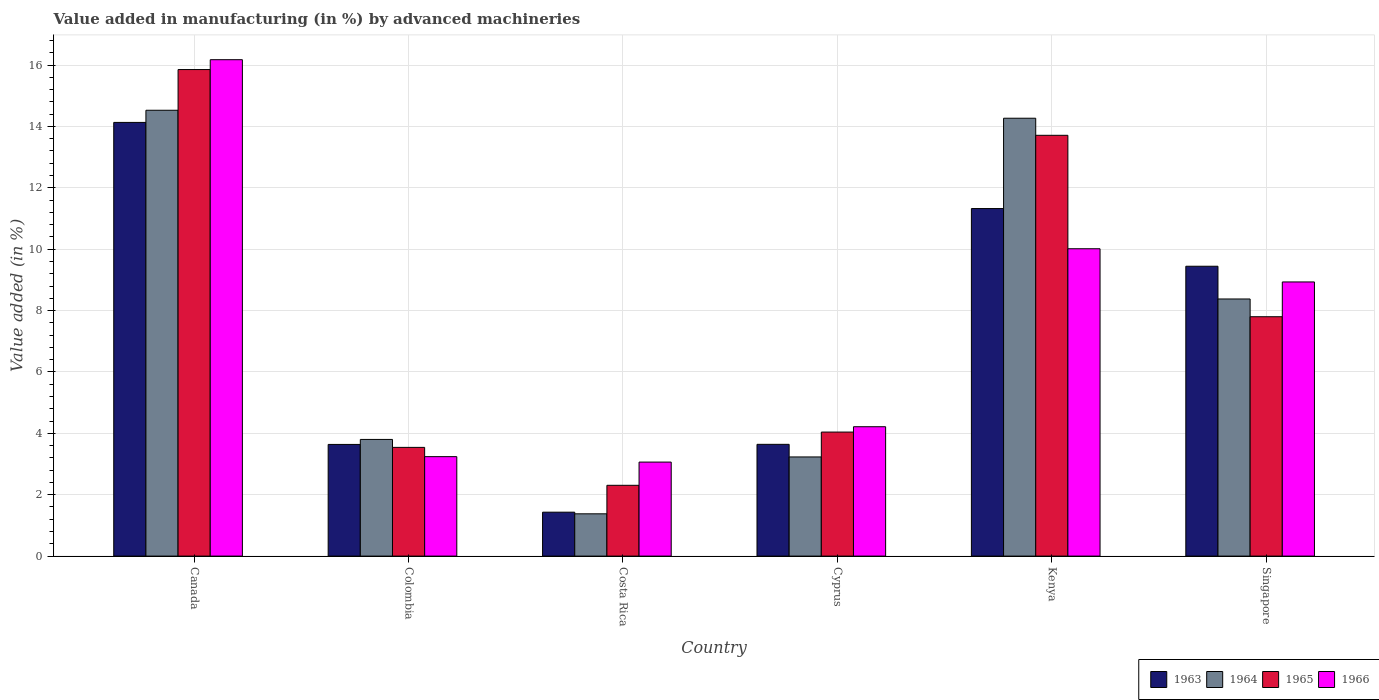What is the label of the 1st group of bars from the left?
Ensure brevity in your answer.  Canada. In how many cases, is the number of bars for a given country not equal to the number of legend labels?
Keep it short and to the point. 0. What is the percentage of value added in manufacturing by advanced machineries in 1966 in Kenya?
Offer a very short reply. 10.01. Across all countries, what is the maximum percentage of value added in manufacturing by advanced machineries in 1966?
Give a very brief answer. 16.17. Across all countries, what is the minimum percentage of value added in manufacturing by advanced machineries in 1964?
Offer a very short reply. 1.38. In which country was the percentage of value added in manufacturing by advanced machineries in 1964 minimum?
Your response must be concise. Costa Rica. What is the total percentage of value added in manufacturing by advanced machineries in 1964 in the graph?
Offer a terse response. 45.58. What is the difference between the percentage of value added in manufacturing by advanced machineries in 1964 in Canada and that in Cyprus?
Make the answer very short. 11.3. What is the difference between the percentage of value added in manufacturing by advanced machineries in 1966 in Singapore and the percentage of value added in manufacturing by advanced machineries in 1963 in Kenya?
Offer a very short reply. -2.39. What is the average percentage of value added in manufacturing by advanced machineries in 1963 per country?
Keep it short and to the point. 7.27. What is the difference between the percentage of value added in manufacturing by advanced machineries of/in 1964 and percentage of value added in manufacturing by advanced machineries of/in 1965 in Canada?
Give a very brief answer. -1.33. In how many countries, is the percentage of value added in manufacturing by advanced machineries in 1966 greater than 0.8 %?
Make the answer very short. 6. What is the ratio of the percentage of value added in manufacturing by advanced machineries in 1964 in Costa Rica to that in Kenya?
Your response must be concise. 0.1. What is the difference between the highest and the second highest percentage of value added in manufacturing by advanced machineries in 1966?
Make the answer very short. 7.24. What is the difference between the highest and the lowest percentage of value added in manufacturing by advanced machineries in 1965?
Your answer should be compact. 13.55. In how many countries, is the percentage of value added in manufacturing by advanced machineries in 1963 greater than the average percentage of value added in manufacturing by advanced machineries in 1963 taken over all countries?
Your answer should be compact. 3. What does the 1st bar from the left in Kenya represents?
Give a very brief answer. 1963. What does the 4th bar from the right in Costa Rica represents?
Offer a terse response. 1963. Is it the case that in every country, the sum of the percentage of value added in manufacturing by advanced machineries in 1965 and percentage of value added in manufacturing by advanced machineries in 1964 is greater than the percentage of value added in manufacturing by advanced machineries in 1966?
Give a very brief answer. Yes. How many countries are there in the graph?
Ensure brevity in your answer.  6. What is the difference between two consecutive major ticks on the Y-axis?
Your response must be concise. 2. Are the values on the major ticks of Y-axis written in scientific E-notation?
Your answer should be very brief. No. Does the graph contain any zero values?
Make the answer very short. No. How many legend labels are there?
Provide a short and direct response. 4. What is the title of the graph?
Ensure brevity in your answer.  Value added in manufacturing (in %) by advanced machineries. Does "1996" appear as one of the legend labels in the graph?
Ensure brevity in your answer.  No. What is the label or title of the Y-axis?
Offer a very short reply. Value added (in %). What is the Value added (in %) of 1963 in Canada?
Keep it short and to the point. 14.13. What is the Value added (in %) of 1964 in Canada?
Keep it short and to the point. 14.53. What is the Value added (in %) of 1965 in Canada?
Your response must be concise. 15.85. What is the Value added (in %) of 1966 in Canada?
Offer a terse response. 16.17. What is the Value added (in %) in 1963 in Colombia?
Ensure brevity in your answer.  3.64. What is the Value added (in %) of 1964 in Colombia?
Keep it short and to the point. 3.8. What is the Value added (in %) of 1965 in Colombia?
Your response must be concise. 3.54. What is the Value added (in %) of 1966 in Colombia?
Offer a terse response. 3.24. What is the Value added (in %) in 1963 in Costa Rica?
Give a very brief answer. 1.43. What is the Value added (in %) of 1964 in Costa Rica?
Offer a terse response. 1.38. What is the Value added (in %) of 1965 in Costa Rica?
Provide a short and direct response. 2.31. What is the Value added (in %) in 1966 in Costa Rica?
Provide a short and direct response. 3.06. What is the Value added (in %) in 1963 in Cyprus?
Make the answer very short. 3.64. What is the Value added (in %) of 1964 in Cyprus?
Provide a short and direct response. 3.23. What is the Value added (in %) in 1965 in Cyprus?
Provide a succinct answer. 4.04. What is the Value added (in %) of 1966 in Cyprus?
Keep it short and to the point. 4.22. What is the Value added (in %) of 1963 in Kenya?
Make the answer very short. 11.32. What is the Value added (in %) in 1964 in Kenya?
Your response must be concise. 14.27. What is the Value added (in %) of 1965 in Kenya?
Offer a terse response. 13.71. What is the Value added (in %) in 1966 in Kenya?
Your response must be concise. 10.01. What is the Value added (in %) of 1963 in Singapore?
Provide a succinct answer. 9.44. What is the Value added (in %) in 1964 in Singapore?
Your answer should be very brief. 8.38. What is the Value added (in %) in 1965 in Singapore?
Make the answer very short. 7.8. What is the Value added (in %) of 1966 in Singapore?
Provide a succinct answer. 8.93. Across all countries, what is the maximum Value added (in %) in 1963?
Give a very brief answer. 14.13. Across all countries, what is the maximum Value added (in %) in 1964?
Keep it short and to the point. 14.53. Across all countries, what is the maximum Value added (in %) in 1965?
Make the answer very short. 15.85. Across all countries, what is the maximum Value added (in %) of 1966?
Offer a terse response. 16.17. Across all countries, what is the minimum Value added (in %) in 1963?
Make the answer very short. 1.43. Across all countries, what is the minimum Value added (in %) in 1964?
Your answer should be compact. 1.38. Across all countries, what is the minimum Value added (in %) in 1965?
Offer a very short reply. 2.31. Across all countries, what is the minimum Value added (in %) in 1966?
Give a very brief answer. 3.06. What is the total Value added (in %) of 1963 in the graph?
Make the answer very short. 43.61. What is the total Value added (in %) in 1964 in the graph?
Your response must be concise. 45.58. What is the total Value added (in %) in 1965 in the graph?
Your answer should be compact. 47.25. What is the total Value added (in %) of 1966 in the graph?
Your answer should be very brief. 45.64. What is the difference between the Value added (in %) of 1963 in Canada and that in Colombia?
Make the answer very short. 10.49. What is the difference between the Value added (in %) in 1964 in Canada and that in Colombia?
Make the answer very short. 10.72. What is the difference between the Value added (in %) in 1965 in Canada and that in Colombia?
Keep it short and to the point. 12.31. What is the difference between the Value added (in %) in 1966 in Canada and that in Colombia?
Provide a short and direct response. 12.93. What is the difference between the Value added (in %) in 1963 in Canada and that in Costa Rica?
Provide a short and direct response. 12.7. What is the difference between the Value added (in %) of 1964 in Canada and that in Costa Rica?
Ensure brevity in your answer.  13.15. What is the difference between the Value added (in %) in 1965 in Canada and that in Costa Rica?
Give a very brief answer. 13.55. What is the difference between the Value added (in %) of 1966 in Canada and that in Costa Rica?
Keep it short and to the point. 13.11. What is the difference between the Value added (in %) in 1963 in Canada and that in Cyprus?
Your answer should be very brief. 10.49. What is the difference between the Value added (in %) of 1964 in Canada and that in Cyprus?
Offer a terse response. 11.3. What is the difference between the Value added (in %) of 1965 in Canada and that in Cyprus?
Provide a short and direct response. 11.81. What is the difference between the Value added (in %) of 1966 in Canada and that in Cyprus?
Ensure brevity in your answer.  11.96. What is the difference between the Value added (in %) in 1963 in Canada and that in Kenya?
Your response must be concise. 2.81. What is the difference between the Value added (in %) in 1964 in Canada and that in Kenya?
Give a very brief answer. 0.26. What is the difference between the Value added (in %) of 1965 in Canada and that in Kenya?
Offer a very short reply. 2.14. What is the difference between the Value added (in %) of 1966 in Canada and that in Kenya?
Provide a short and direct response. 6.16. What is the difference between the Value added (in %) of 1963 in Canada and that in Singapore?
Provide a short and direct response. 4.69. What is the difference between the Value added (in %) in 1964 in Canada and that in Singapore?
Offer a terse response. 6.15. What is the difference between the Value added (in %) in 1965 in Canada and that in Singapore?
Provide a short and direct response. 8.05. What is the difference between the Value added (in %) of 1966 in Canada and that in Singapore?
Your answer should be compact. 7.24. What is the difference between the Value added (in %) in 1963 in Colombia and that in Costa Rica?
Your response must be concise. 2.21. What is the difference between the Value added (in %) in 1964 in Colombia and that in Costa Rica?
Give a very brief answer. 2.42. What is the difference between the Value added (in %) of 1965 in Colombia and that in Costa Rica?
Offer a very short reply. 1.24. What is the difference between the Value added (in %) of 1966 in Colombia and that in Costa Rica?
Your response must be concise. 0.18. What is the difference between the Value added (in %) in 1963 in Colombia and that in Cyprus?
Make the answer very short. -0. What is the difference between the Value added (in %) of 1964 in Colombia and that in Cyprus?
Your response must be concise. 0.57. What is the difference between the Value added (in %) in 1965 in Colombia and that in Cyprus?
Your response must be concise. -0.5. What is the difference between the Value added (in %) of 1966 in Colombia and that in Cyprus?
Offer a terse response. -0.97. What is the difference between the Value added (in %) of 1963 in Colombia and that in Kenya?
Ensure brevity in your answer.  -7.69. What is the difference between the Value added (in %) in 1964 in Colombia and that in Kenya?
Your answer should be very brief. -10.47. What is the difference between the Value added (in %) of 1965 in Colombia and that in Kenya?
Offer a terse response. -10.17. What is the difference between the Value added (in %) of 1966 in Colombia and that in Kenya?
Your answer should be compact. -6.77. What is the difference between the Value added (in %) of 1963 in Colombia and that in Singapore?
Your answer should be compact. -5.81. What is the difference between the Value added (in %) of 1964 in Colombia and that in Singapore?
Provide a short and direct response. -4.58. What is the difference between the Value added (in %) in 1965 in Colombia and that in Singapore?
Your answer should be compact. -4.26. What is the difference between the Value added (in %) in 1966 in Colombia and that in Singapore?
Your answer should be very brief. -5.69. What is the difference between the Value added (in %) of 1963 in Costa Rica and that in Cyprus?
Offer a very short reply. -2.21. What is the difference between the Value added (in %) of 1964 in Costa Rica and that in Cyprus?
Provide a succinct answer. -1.85. What is the difference between the Value added (in %) of 1965 in Costa Rica and that in Cyprus?
Offer a very short reply. -1.73. What is the difference between the Value added (in %) in 1966 in Costa Rica and that in Cyprus?
Provide a succinct answer. -1.15. What is the difference between the Value added (in %) of 1963 in Costa Rica and that in Kenya?
Give a very brief answer. -9.89. What is the difference between the Value added (in %) in 1964 in Costa Rica and that in Kenya?
Give a very brief answer. -12.89. What is the difference between the Value added (in %) of 1965 in Costa Rica and that in Kenya?
Your answer should be compact. -11.4. What is the difference between the Value added (in %) in 1966 in Costa Rica and that in Kenya?
Provide a short and direct response. -6.95. What is the difference between the Value added (in %) in 1963 in Costa Rica and that in Singapore?
Your answer should be very brief. -8.01. What is the difference between the Value added (in %) in 1964 in Costa Rica and that in Singapore?
Offer a terse response. -7. What is the difference between the Value added (in %) in 1965 in Costa Rica and that in Singapore?
Your answer should be compact. -5.49. What is the difference between the Value added (in %) of 1966 in Costa Rica and that in Singapore?
Keep it short and to the point. -5.87. What is the difference between the Value added (in %) in 1963 in Cyprus and that in Kenya?
Your answer should be compact. -7.68. What is the difference between the Value added (in %) of 1964 in Cyprus and that in Kenya?
Offer a terse response. -11.04. What is the difference between the Value added (in %) of 1965 in Cyprus and that in Kenya?
Your response must be concise. -9.67. What is the difference between the Value added (in %) of 1966 in Cyprus and that in Kenya?
Keep it short and to the point. -5.8. What is the difference between the Value added (in %) in 1963 in Cyprus and that in Singapore?
Make the answer very short. -5.8. What is the difference between the Value added (in %) of 1964 in Cyprus and that in Singapore?
Ensure brevity in your answer.  -5.15. What is the difference between the Value added (in %) in 1965 in Cyprus and that in Singapore?
Your answer should be compact. -3.76. What is the difference between the Value added (in %) of 1966 in Cyprus and that in Singapore?
Keep it short and to the point. -4.72. What is the difference between the Value added (in %) of 1963 in Kenya and that in Singapore?
Keep it short and to the point. 1.88. What is the difference between the Value added (in %) in 1964 in Kenya and that in Singapore?
Your answer should be very brief. 5.89. What is the difference between the Value added (in %) in 1965 in Kenya and that in Singapore?
Your answer should be very brief. 5.91. What is the difference between the Value added (in %) of 1966 in Kenya and that in Singapore?
Offer a terse response. 1.08. What is the difference between the Value added (in %) in 1963 in Canada and the Value added (in %) in 1964 in Colombia?
Provide a short and direct response. 10.33. What is the difference between the Value added (in %) of 1963 in Canada and the Value added (in %) of 1965 in Colombia?
Ensure brevity in your answer.  10.59. What is the difference between the Value added (in %) of 1963 in Canada and the Value added (in %) of 1966 in Colombia?
Make the answer very short. 10.89. What is the difference between the Value added (in %) of 1964 in Canada and the Value added (in %) of 1965 in Colombia?
Give a very brief answer. 10.98. What is the difference between the Value added (in %) in 1964 in Canada and the Value added (in %) in 1966 in Colombia?
Give a very brief answer. 11.29. What is the difference between the Value added (in %) in 1965 in Canada and the Value added (in %) in 1966 in Colombia?
Keep it short and to the point. 12.61. What is the difference between the Value added (in %) in 1963 in Canada and the Value added (in %) in 1964 in Costa Rica?
Your response must be concise. 12.75. What is the difference between the Value added (in %) of 1963 in Canada and the Value added (in %) of 1965 in Costa Rica?
Your answer should be very brief. 11.82. What is the difference between the Value added (in %) of 1963 in Canada and the Value added (in %) of 1966 in Costa Rica?
Your response must be concise. 11.07. What is the difference between the Value added (in %) of 1964 in Canada and the Value added (in %) of 1965 in Costa Rica?
Make the answer very short. 12.22. What is the difference between the Value added (in %) of 1964 in Canada and the Value added (in %) of 1966 in Costa Rica?
Give a very brief answer. 11.46. What is the difference between the Value added (in %) of 1965 in Canada and the Value added (in %) of 1966 in Costa Rica?
Offer a terse response. 12.79. What is the difference between the Value added (in %) of 1963 in Canada and the Value added (in %) of 1964 in Cyprus?
Provide a short and direct response. 10.9. What is the difference between the Value added (in %) in 1963 in Canada and the Value added (in %) in 1965 in Cyprus?
Offer a very short reply. 10.09. What is the difference between the Value added (in %) of 1963 in Canada and the Value added (in %) of 1966 in Cyprus?
Give a very brief answer. 9.92. What is the difference between the Value added (in %) in 1964 in Canada and the Value added (in %) in 1965 in Cyprus?
Provide a short and direct response. 10.49. What is the difference between the Value added (in %) of 1964 in Canada and the Value added (in %) of 1966 in Cyprus?
Your answer should be compact. 10.31. What is the difference between the Value added (in %) of 1965 in Canada and the Value added (in %) of 1966 in Cyprus?
Your answer should be very brief. 11.64. What is the difference between the Value added (in %) of 1963 in Canada and the Value added (in %) of 1964 in Kenya?
Your answer should be compact. -0.14. What is the difference between the Value added (in %) of 1963 in Canada and the Value added (in %) of 1965 in Kenya?
Your response must be concise. 0.42. What is the difference between the Value added (in %) in 1963 in Canada and the Value added (in %) in 1966 in Kenya?
Provide a short and direct response. 4.12. What is the difference between the Value added (in %) in 1964 in Canada and the Value added (in %) in 1965 in Kenya?
Your response must be concise. 0.82. What is the difference between the Value added (in %) in 1964 in Canada and the Value added (in %) in 1966 in Kenya?
Your answer should be compact. 4.51. What is the difference between the Value added (in %) in 1965 in Canada and the Value added (in %) in 1966 in Kenya?
Make the answer very short. 5.84. What is the difference between the Value added (in %) of 1963 in Canada and the Value added (in %) of 1964 in Singapore?
Your answer should be compact. 5.75. What is the difference between the Value added (in %) of 1963 in Canada and the Value added (in %) of 1965 in Singapore?
Your answer should be compact. 6.33. What is the difference between the Value added (in %) of 1963 in Canada and the Value added (in %) of 1966 in Singapore?
Your answer should be compact. 5.2. What is the difference between the Value added (in %) in 1964 in Canada and the Value added (in %) in 1965 in Singapore?
Your response must be concise. 6.73. What is the difference between the Value added (in %) of 1964 in Canada and the Value added (in %) of 1966 in Singapore?
Your answer should be very brief. 5.59. What is the difference between the Value added (in %) of 1965 in Canada and the Value added (in %) of 1966 in Singapore?
Offer a very short reply. 6.92. What is the difference between the Value added (in %) in 1963 in Colombia and the Value added (in %) in 1964 in Costa Rica?
Your response must be concise. 2.26. What is the difference between the Value added (in %) in 1963 in Colombia and the Value added (in %) in 1965 in Costa Rica?
Make the answer very short. 1.33. What is the difference between the Value added (in %) of 1963 in Colombia and the Value added (in %) of 1966 in Costa Rica?
Give a very brief answer. 0.57. What is the difference between the Value added (in %) of 1964 in Colombia and the Value added (in %) of 1965 in Costa Rica?
Offer a terse response. 1.49. What is the difference between the Value added (in %) in 1964 in Colombia and the Value added (in %) in 1966 in Costa Rica?
Provide a short and direct response. 0.74. What is the difference between the Value added (in %) of 1965 in Colombia and the Value added (in %) of 1966 in Costa Rica?
Your answer should be very brief. 0.48. What is the difference between the Value added (in %) in 1963 in Colombia and the Value added (in %) in 1964 in Cyprus?
Your answer should be very brief. 0.41. What is the difference between the Value added (in %) in 1963 in Colombia and the Value added (in %) in 1965 in Cyprus?
Keep it short and to the point. -0.4. What is the difference between the Value added (in %) in 1963 in Colombia and the Value added (in %) in 1966 in Cyprus?
Offer a terse response. -0.58. What is the difference between the Value added (in %) in 1964 in Colombia and the Value added (in %) in 1965 in Cyprus?
Your answer should be very brief. -0.24. What is the difference between the Value added (in %) in 1964 in Colombia and the Value added (in %) in 1966 in Cyprus?
Give a very brief answer. -0.41. What is the difference between the Value added (in %) of 1965 in Colombia and the Value added (in %) of 1966 in Cyprus?
Keep it short and to the point. -0.67. What is the difference between the Value added (in %) of 1963 in Colombia and the Value added (in %) of 1964 in Kenya?
Your response must be concise. -10.63. What is the difference between the Value added (in %) in 1963 in Colombia and the Value added (in %) in 1965 in Kenya?
Your response must be concise. -10.07. What is the difference between the Value added (in %) in 1963 in Colombia and the Value added (in %) in 1966 in Kenya?
Your answer should be very brief. -6.38. What is the difference between the Value added (in %) in 1964 in Colombia and the Value added (in %) in 1965 in Kenya?
Your answer should be compact. -9.91. What is the difference between the Value added (in %) of 1964 in Colombia and the Value added (in %) of 1966 in Kenya?
Your answer should be very brief. -6.21. What is the difference between the Value added (in %) in 1965 in Colombia and the Value added (in %) in 1966 in Kenya?
Give a very brief answer. -6.47. What is the difference between the Value added (in %) of 1963 in Colombia and the Value added (in %) of 1964 in Singapore?
Your answer should be compact. -4.74. What is the difference between the Value added (in %) in 1963 in Colombia and the Value added (in %) in 1965 in Singapore?
Provide a short and direct response. -4.16. What is the difference between the Value added (in %) in 1963 in Colombia and the Value added (in %) in 1966 in Singapore?
Provide a succinct answer. -5.29. What is the difference between the Value added (in %) of 1964 in Colombia and the Value added (in %) of 1965 in Singapore?
Offer a terse response. -4. What is the difference between the Value added (in %) of 1964 in Colombia and the Value added (in %) of 1966 in Singapore?
Your answer should be very brief. -5.13. What is the difference between the Value added (in %) in 1965 in Colombia and the Value added (in %) in 1966 in Singapore?
Provide a short and direct response. -5.39. What is the difference between the Value added (in %) in 1963 in Costa Rica and the Value added (in %) in 1964 in Cyprus?
Provide a short and direct response. -1.8. What is the difference between the Value added (in %) in 1963 in Costa Rica and the Value added (in %) in 1965 in Cyprus?
Your answer should be very brief. -2.61. What is the difference between the Value added (in %) of 1963 in Costa Rica and the Value added (in %) of 1966 in Cyprus?
Your response must be concise. -2.78. What is the difference between the Value added (in %) in 1964 in Costa Rica and the Value added (in %) in 1965 in Cyprus?
Provide a succinct answer. -2.66. What is the difference between the Value added (in %) of 1964 in Costa Rica and the Value added (in %) of 1966 in Cyprus?
Offer a very short reply. -2.84. What is the difference between the Value added (in %) of 1965 in Costa Rica and the Value added (in %) of 1966 in Cyprus?
Your answer should be compact. -1.91. What is the difference between the Value added (in %) in 1963 in Costa Rica and the Value added (in %) in 1964 in Kenya?
Offer a very short reply. -12.84. What is the difference between the Value added (in %) in 1963 in Costa Rica and the Value added (in %) in 1965 in Kenya?
Keep it short and to the point. -12.28. What is the difference between the Value added (in %) in 1963 in Costa Rica and the Value added (in %) in 1966 in Kenya?
Offer a very short reply. -8.58. What is the difference between the Value added (in %) in 1964 in Costa Rica and the Value added (in %) in 1965 in Kenya?
Your answer should be very brief. -12.33. What is the difference between the Value added (in %) of 1964 in Costa Rica and the Value added (in %) of 1966 in Kenya?
Your answer should be compact. -8.64. What is the difference between the Value added (in %) of 1965 in Costa Rica and the Value added (in %) of 1966 in Kenya?
Give a very brief answer. -7.71. What is the difference between the Value added (in %) of 1963 in Costa Rica and the Value added (in %) of 1964 in Singapore?
Make the answer very short. -6.95. What is the difference between the Value added (in %) of 1963 in Costa Rica and the Value added (in %) of 1965 in Singapore?
Your answer should be very brief. -6.37. What is the difference between the Value added (in %) in 1963 in Costa Rica and the Value added (in %) in 1966 in Singapore?
Keep it short and to the point. -7.5. What is the difference between the Value added (in %) in 1964 in Costa Rica and the Value added (in %) in 1965 in Singapore?
Offer a very short reply. -6.42. What is the difference between the Value added (in %) in 1964 in Costa Rica and the Value added (in %) in 1966 in Singapore?
Your response must be concise. -7.55. What is the difference between the Value added (in %) in 1965 in Costa Rica and the Value added (in %) in 1966 in Singapore?
Your response must be concise. -6.63. What is the difference between the Value added (in %) of 1963 in Cyprus and the Value added (in %) of 1964 in Kenya?
Provide a short and direct response. -10.63. What is the difference between the Value added (in %) in 1963 in Cyprus and the Value added (in %) in 1965 in Kenya?
Provide a short and direct response. -10.07. What is the difference between the Value added (in %) in 1963 in Cyprus and the Value added (in %) in 1966 in Kenya?
Offer a very short reply. -6.37. What is the difference between the Value added (in %) of 1964 in Cyprus and the Value added (in %) of 1965 in Kenya?
Your response must be concise. -10.48. What is the difference between the Value added (in %) in 1964 in Cyprus and the Value added (in %) in 1966 in Kenya?
Your answer should be compact. -6.78. What is the difference between the Value added (in %) in 1965 in Cyprus and the Value added (in %) in 1966 in Kenya?
Give a very brief answer. -5.97. What is the difference between the Value added (in %) of 1963 in Cyprus and the Value added (in %) of 1964 in Singapore?
Offer a terse response. -4.74. What is the difference between the Value added (in %) of 1963 in Cyprus and the Value added (in %) of 1965 in Singapore?
Provide a short and direct response. -4.16. What is the difference between the Value added (in %) of 1963 in Cyprus and the Value added (in %) of 1966 in Singapore?
Your answer should be compact. -5.29. What is the difference between the Value added (in %) of 1964 in Cyprus and the Value added (in %) of 1965 in Singapore?
Provide a short and direct response. -4.57. What is the difference between the Value added (in %) of 1964 in Cyprus and the Value added (in %) of 1966 in Singapore?
Offer a very short reply. -5.7. What is the difference between the Value added (in %) in 1965 in Cyprus and the Value added (in %) in 1966 in Singapore?
Your answer should be compact. -4.89. What is the difference between the Value added (in %) in 1963 in Kenya and the Value added (in %) in 1964 in Singapore?
Ensure brevity in your answer.  2.95. What is the difference between the Value added (in %) of 1963 in Kenya and the Value added (in %) of 1965 in Singapore?
Make the answer very short. 3.52. What is the difference between the Value added (in %) in 1963 in Kenya and the Value added (in %) in 1966 in Singapore?
Offer a terse response. 2.39. What is the difference between the Value added (in %) in 1964 in Kenya and the Value added (in %) in 1965 in Singapore?
Keep it short and to the point. 6.47. What is the difference between the Value added (in %) of 1964 in Kenya and the Value added (in %) of 1966 in Singapore?
Make the answer very short. 5.33. What is the difference between the Value added (in %) in 1965 in Kenya and the Value added (in %) in 1966 in Singapore?
Provide a succinct answer. 4.78. What is the average Value added (in %) of 1963 per country?
Your response must be concise. 7.27. What is the average Value added (in %) of 1964 per country?
Offer a very short reply. 7.6. What is the average Value added (in %) of 1965 per country?
Make the answer very short. 7.88. What is the average Value added (in %) of 1966 per country?
Your answer should be compact. 7.61. What is the difference between the Value added (in %) of 1963 and Value added (in %) of 1964 in Canada?
Your answer should be very brief. -0.4. What is the difference between the Value added (in %) in 1963 and Value added (in %) in 1965 in Canada?
Make the answer very short. -1.72. What is the difference between the Value added (in %) in 1963 and Value added (in %) in 1966 in Canada?
Offer a terse response. -2.04. What is the difference between the Value added (in %) in 1964 and Value added (in %) in 1965 in Canada?
Your response must be concise. -1.33. What is the difference between the Value added (in %) of 1964 and Value added (in %) of 1966 in Canada?
Ensure brevity in your answer.  -1.65. What is the difference between the Value added (in %) in 1965 and Value added (in %) in 1966 in Canada?
Give a very brief answer. -0.32. What is the difference between the Value added (in %) in 1963 and Value added (in %) in 1964 in Colombia?
Provide a succinct answer. -0.16. What is the difference between the Value added (in %) of 1963 and Value added (in %) of 1965 in Colombia?
Keep it short and to the point. 0.1. What is the difference between the Value added (in %) of 1963 and Value added (in %) of 1966 in Colombia?
Make the answer very short. 0.4. What is the difference between the Value added (in %) in 1964 and Value added (in %) in 1965 in Colombia?
Offer a very short reply. 0.26. What is the difference between the Value added (in %) in 1964 and Value added (in %) in 1966 in Colombia?
Your answer should be compact. 0.56. What is the difference between the Value added (in %) in 1965 and Value added (in %) in 1966 in Colombia?
Ensure brevity in your answer.  0.3. What is the difference between the Value added (in %) in 1963 and Value added (in %) in 1964 in Costa Rica?
Ensure brevity in your answer.  0.05. What is the difference between the Value added (in %) in 1963 and Value added (in %) in 1965 in Costa Rica?
Keep it short and to the point. -0.88. What is the difference between the Value added (in %) in 1963 and Value added (in %) in 1966 in Costa Rica?
Your response must be concise. -1.63. What is the difference between the Value added (in %) in 1964 and Value added (in %) in 1965 in Costa Rica?
Your answer should be very brief. -0.93. What is the difference between the Value added (in %) of 1964 and Value added (in %) of 1966 in Costa Rica?
Make the answer very short. -1.69. What is the difference between the Value added (in %) in 1965 and Value added (in %) in 1966 in Costa Rica?
Give a very brief answer. -0.76. What is the difference between the Value added (in %) in 1963 and Value added (in %) in 1964 in Cyprus?
Offer a very short reply. 0.41. What is the difference between the Value added (in %) in 1963 and Value added (in %) in 1965 in Cyprus?
Make the answer very short. -0.4. What is the difference between the Value added (in %) of 1963 and Value added (in %) of 1966 in Cyprus?
Keep it short and to the point. -0.57. What is the difference between the Value added (in %) of 1964 and Value added (in %) of 1965 in Cyprus?
Provide a short and direct response. -0.81. What is the difference between the Value added (in %) in 1964 and Value added (in %) in 1966 in Cyprus?
Offer a very short reply. -0.98. What is the difference between the Value added (in %) of 1965 and Value added (in %) of 1966 in Cyprus?
Provide a succinct answer. -0.17. What is the difference between the Value added (in %) in 1963 and Value added (in %) in 1964 in Kenya?
Your response must be concise. -2.94. What is the difference between the Value added (in %) in 1963 and Value added (in %) in 1965 in Kenya?
Provide a succinct answer. -2.39. What is the difference between the Value added (in %) of 1963 and Value added (in %) of 1966 in Kenya?
Provide a succinct answer. 1.31. What is the difference between the Value added (in %) of 1964 and Value added (in %) of 1965 in Kenya?
Ensure brevity in your answer.  0.56. What is the difference between the Value added (in %) of 1964 and Value added (in %) of 1966 in Kenya?
Ensure brevity in your answer.  4.25. What is the difference between the Value added (in %) of 1965 and Value added (in %) of 1966 in Kenya?
Make the answer very short. 3.7. What is the difference between the Value added (in %) in 1963 and Value added (in %) in 1964 in Singapore?
Offer a terse response. 1.07. What is the difference between the Value added (in %) in 1963 and Value added (in %) in 1965 in Singapore?
Your answer should be very brief. 1.64. What is the difference between the Value added (in %) in 1963 and Value added (in %) in 1966 in Singapore?
Offer a terse response. 0.51. What is the difference between the Value added (in %) in 1964 and Value added (in %) in 1965 in Singapore?
Your response must be concise. 0.58. What is the difference between the Value added (in %) in 1964 and Value added (in %) in 1966 in Singapore?
Your response must be concise. -0.55. What is the difference between the Value added (in %) in 1965 and Value added (in %) in 1966 in Singapore?
Keep it short and to the point. -1.13. What is the ratio of the Value added (in %) in 1963 in Canada to that in Colombia?
Ensure brevity in your answer.  3.88. What is the ratio of the Value added (in %) in 1964 in Canada to that in Colombia?
Your response must be concise. 3.82. What is the ratio of the Value added (in %) in 1965 in Canada to that in Colombia?
Your answer should be compact. 4.48. What is the ratio of the Value added (in %) in 1966 in Canada to that in Colombia?
Provide a short and direct response. 4.99. What is the ratio of the Value added (in %) in 1963 in Canada to that in Costa Rica?
Your answer should be compact. 9.87. What is the ratio of the Value added (in %) in 1964 in Canada to that in Costa Rica?
Offer a very short reply. 10.54. What is the ratio of the Value added (in %) in 1965 in Canada to that in Costa Rica?
Ensure brevity in your answer.  6.87. What is the ratio of the Value added (in %) in 1966 in Canada to that in Costa Rica?
Give a very brief answer. 5.28. What is the ratio of the Value added (in %) in 1963 in Canada to that in Cyprus?
Ensure brevity in your answer.  3.88. What is the ratio of the Value added (in %) in 1964 in Canada to that in Cyprus?
Offer a terse response. 4.5. What is the ratio of the Value added (in %) of 1965 in Canada to that in Cyprus?
Provide a short and direct response. 3.92. What is the ratio of the Value added (in %) in 1966 in Canada to that in Cyprus?
Offer a very short reply. 3.84. What is the ratio of the Value added (in %) in 1963 in Canada to that in Kenya?
Provide a succinct answer. 1.25. What is the ratio of the Value added (in %) in 1964 in Canada to that in Kenya?
Ensure brevity in your answer.  1.02. What is the ratio of the Value added (in %) in 1965 in Canada to that in Kenya?
Give a very brief answer. 1.16. What is the ratio of the Value added (in %) of 1966 in Canada to that in Kenya?
Provide a short and direct response. 1.62. What is the ratio of the Value added (in %) in 1963 in Canada to that in Singapore?
Give a very brief answer. 1.5. What is the ratio of the Value added (in %) in 1964 in Canada to that in Singapore?
Provide a short and direct response. 1.73. What is the ratio of the Value added (in %) in 1965 in Canada to that in Singapore?
Make the answer very short. 2.03. What is the ratio of the Value added (in %) in 1966 in Canada to that in Singapore?
Provide a short and direct response. 1.81. What is the ratio of the Value added (in %) of 1963 in Colombia to that in Costa Rica?
Make the answer very short. 2.54. What is the ratio of the Value added (in %) of 1964 in Colombia to that in Costa Rica?
Offer a terse response. 2.76. What is the ratio of the Value added (in %) of 1965 in Colombia to that in Costa Rica?
Ensure brevity in your answer.  1.54. What is the ratio of the Value added (in %) of 1966 in Colombia to that in Costa Rica?
Offer a terse response. 1.06. What is the ratio of the Value added (in %) of 1964 in Colombia to that in Cyprus?
Your answer should be compact. 1.18. What is the ratio of the Value added (in %) of 1965 in Colombia to that in Cyprus?
Your answer should be very brief. 0.88. What is the ratio of the Value added (in %) of 1966 in Colombia to that in Cyprus?
Give a very brief answer. 0.77. What is the ratio of the Value added (in %) in 1963 in Colombia to that in Kenya?
Give a very brief answer. 0.32. What is the ratio of the Value added (in %) in 1964 in Colombia to that in Kenya?
Offer a very short reply. 0.27. What is the ratio of the Value added (in %) of 1965 in Colombia to that in Kenya?
Offer a terse response. 0.26. What is the ratio of the Value added (in %) of 1966 in Colombia to that in Kenya?
Your answer should be very brief. 0.32. What is the ratio of the Value added (in %) in 1963 in Colombia to that in Singapore?
Your answer should be very brief. 0.39. What is the ratio of the Value added (in %) of 1964 in Colombia to that in Singapore?
Ensure brevity in your answer.  0.45. What is the ratio of the Value added (in %) of 1965 in Colombia to that in Singapore?
Provide a succinct answer. 0.45. What is the ratio of the Value added (in %) in 1966 in Colombia to that in Singapore?
Your answer should be very brief. 0.36. What is the ratio of the Value added (in %) in 1963 in Costa Rica to that in Cyprus?
Your response must be concise. 0.39. What is the ratio of the Value added (in %) in 1964 in Costa Rica to that in Cyprus?
Your answer should be very brief. 0.43. What is the ratio of the Value added (in %) in 1965 in Costa Rica to that in Cyprus?
Provide a short and direct response. 0.57. What is the ratio of the Value added (in %) in 1966 in Costa Rica to that in Cyprus?
Provide a succinct answer. 0.73. What is the ratio of the Value added (in %) in 1963 in Costa Rica to that in Kenya?
Give a very brief answer. 0.13. What is the ratio of the Value added (in %) of 1964 in Costa Rica to that in Kenya?
Your answer should be compact. 0.1. What is the ratio of the Value added (in %) of 1965 in Costa Rica to that in Kenya?
Your answer should be compact. 0.17. What is the ratio of the Value added (in %) of 1966 in Costa Rica to that in Kenya?
Your response must be concise. 0.31. What is the ratio of the Value added (in %) in 1963 in Costa Rica to that in Singapore?
Provide a short and direct response. 0.15. What is the ratio of the Value added (in %) in 1964 in Costa Rica to that in Singapore?
Your response must be concise. 0.16. What is the ratio of the Value added (in %) in 1965 in Costa Rica to that in Singapore?
Your response must be concise. 0.3. What is the ratio of the Value added (in %) in 1966 in Costa Rica to that in Singapore?
Make the answer very short. 0.34. What is the ratio of the Value added (in %) of 1963 in Cyprus to that in Kenya?
Keep it short and to the point. 0.32. What is the ratio of the Value added (in %) of 1964 in Cyprus to that in Kenya?
Provide a succinct answer. 0.23. What is the ratio of the Value added (in %) in 1965 in Cyprus to that in Kenya?
Give a very brief answer. 0.29. What is the ratio of the Value added (in %) in 1966 in Cyprus to that in Kenya?
Your response must be concise. 0.42. What is the ratio of the Value added (in %) in 1963 in Cyprus to that in Singapore?
Your response must be concise. 0.39. What is the ratio of the Value added (in %) in 1964 in Cyprus to that in Singapore?
Ensure brevity in your answer.  0.39. What is the ratio of the Value added (in %) of 1965 in Cyprus to that in Singapore?
Provide a short and direct response. 0.52. What is the ratio of the Value added (in %) of 1966 in Cyprus to that in Singapore?
Keep it short and to the point. 0.47. What is the ratio of the Value added (in %) of 1963 in Kenya to that in Singapore?
Offer a very short reply. 1.2. What is the ratio of the Value added (in %) in 1964 in Kenya to that in Singapore?
Your answer should be compact. 1.7. What is the ratio of the Value added (in %) of 1965 in Kenya to that in Singapore?
Your answer should be very brief. 1.76. What is the ratio of the Value added (in %) of 1966 in Kenya to that in Singapore?
Your response must be concise. 1.12. What is the difference between the highest and the second highest Value added (in %) in 1963?
Provide a short and direct response. 2.81. What is the difference between the highest and the second highest Value added (in %) of 1964?
Keep it short and to the point. 0.26. What is the difference between the highest and the second highest Value added (in %) in 1965?
Provide a short and direct response. 2.14. What is the difference between the highest and the second highest Value added (in %) of 1966?
Your answer should be very brief. 6.16. What is the difference between the highest and the lowest Value added (in %) of 1963?
Make the answer very short. 12.7. What is the difference between the highest and the lowest Value added (in %) in 1964?
Offer a terse response. 13.15. What is the difference between the highest and the lowest Value added (in %) of 1965?
Your response must be concise. 13.55. What is the difference between the highest and the lowest Value added (in %) in 1966?
Provide a short and direct response. 13.11. 